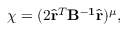Convert formula to latex. <formula><loc_0><loc_0><loc_500><loc_500>\chi = ( 2 \hat { \mathbf r } ^ { T } B ^ { - 1 } \hat { \mathbf r } ) ^ { \mu } ,</formula> 